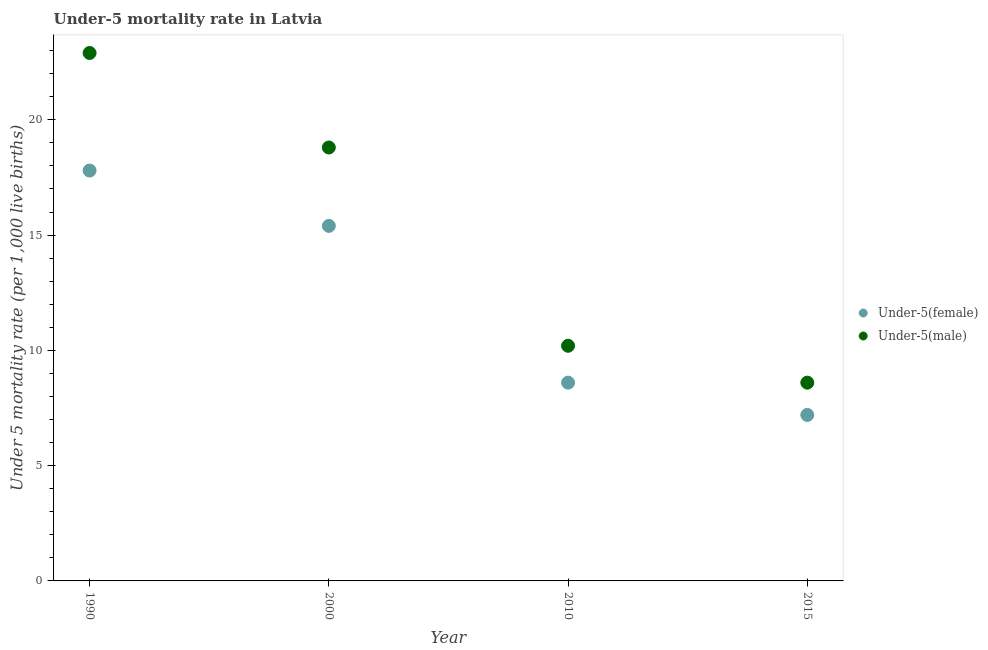Is the number of dotlines equal to the number of legend labels?
Offer a terse response. Yes. What is the under-5 male mortality rate in 2010?
Make the answer very short. 10.2. Across all years, what is the maximum under-5 female mortality rate?
Give a very brief answer. 17.8. In which year was the under-5 male mortality rate maximum?
Your answer should be very brief. 1990. In which year was the under-5 female mortality rate minimum?
Your response must be concise. 2015. What is the total under-5 male mortality rate in the graph?
Your response must be concise. 60.5. What is the difference between the under-5 male mortality rate in 1990 and that in 2015?
Your response must be concise. 14.3. What is the difference between the under-5 female mortality rate in 2010 and the under-5 male mortality rate in 1990?
Your answer should be very brief. -14.3. What is the average under-5 female mortality rate per year?
Offer a terse response. 12.25. In the year 2000, what is the difference between the under-5 male mortality rate and under-5 female mortality rate?
Your answer should be compact. 3.4. In how many years, is the under-5 female mortality rate greater than 22?
Offer a very short reply. 0. What is the ratio of the under-5 male mortality rate in 1990 to that in 2015?
Provide a short and direct response. 2.66. What is the difference between the highest and the second highest under-5 female mortality rate?
Your answer should be very brief. 2.4. What is the difference between the highest and the lowest under-5 female mortality rate?
Give a very brief answer. 10.6. Is the sum of the under-5 female mortality rate in 2010 and 2015 greater than the maximum under-5 male mortality rate across all years?
Offer a very short reply. No. Does the under-5 female mortality rate monotonically increase over the years?
Your response must be concise. No. Is the under-5 male mortality rate strictly greater than the under-5 female mortality rate over the years?
Ensure brevity in your answer.  Yes. How many dotlines are there?
Your answer should be very brief. 2. How many years are there in the graph?
Your answer should be very brief. 4. Does the graph contain any zero values?
Provide a succinct answer. No. How many legend labels are there?
Make the answer very short. 2. What is the title of the graph?
Give a very brief answer. Under-5 mortality rate in Latvia. Does "Primary completion rate" appear as one of the legend labels in the graph?
Provide a short and direct response. No. What is the label or title of the X-axis?
Your response must be concise. Year. What is the label or title of the Y-axis?
Give a very brief answer. Under 5 mortality rate (per 1,0 live births). What is the Under 5 mortality rate (per 1,000 live births) in Under-5(male) in 1990?
Ensure brevity in your answer.  22.9. What is the Under 5 mortality rate (per 1,000 live births) of Under-5(male) in 2000?
Provide a short and direct response. 18.8. What is the Under 5 mortality rate (per 1,000 live births) of Under-5(female) in 2015?
Provide a succinct answer. 7.2. What is the Under 5 mortality rate (per 1,000 live births) in Under-5(male) in 2015?
Offer a terse response. 8.6. Across all years, what is the maximum Under 5 mortality rate (per 1,000 live births) in Under-5(male)?
Offer a very short reply. 22.9. Across all years, what is the minimum Under 5 mortality rate (per 1,000 live births) in Under-5(female)?
Your answer should be compact. 7.2. What is the total Under 5 mortality rate (per 1,000 live births) in Under-5(female) in the graph?
Your answer should be compact. 49. What is the total Under 5 mortality rate (per 1,000 live births) of Under-5(male) in the graph?
Provide a short and direct response. 60.5. What is the difference between the Under 5 mortality rate (per 1,000 live births) of Under-5(male) in 1990 and that in 2000?
Provide a succinct answer. 4.1. What is the difference between the Under 5 mortality rate (per 1,000 live births) in Under-5(female) in 1990 and that in 2010?
Provide a succinct answer. 9.2. What is the difference between the Under 5 mortality rate (per 1,000 live births) of Under-5(female) in 1990 and that in 2015?
Offer a terse response. 10.6. What is the difference between the Under 5 mortality rate (per 1,000 live births) in Under-5(male) in 2000 and that in 2015?
Make the answer very short. 10.2. What is the difference between the Under 5 mortality rate (per 1,000 live births) in Under-5(female) in 1990 and the Under 5 mortality rate (per 1,000 live births) in Under-5(male) in 2000?
Provide a short and direct response. -1. What is the difference between the Under 5 mortality rate (per 1,000 live births) in Under-5(female) in 2000 and the Under 5 mortality rate (per 1,000 live births) in Under-5(male) in 2010?
Offer a very short reply. 5.2. What is the difference between the Under 5 mortality rate (per 1,000 live births) of Under-5(female) in 2010 and the Under 5 mortality rate (per 1,000 live births) of Under-5(male) in 2015?
Your answer should be very brief. 0. What is the average Under 5 mortality rate (per 1,000 live births) in Under-5(female) per year?
Your response must be concise. 12.25. What is the average Under 5 mortality rate (per 1,000 live births) in Under-5(male) per year?
Provide a short and direct response. 15.12. In the year 2015, what is the difference between the Under 5 mortality rate (per 1,000 live births) of Under-5(female) and Under 5 mortality rate (per 1,000 live births) of Under-5(male)?
Provide a short and direct response. -1.4. What is the ratio of the Under 5 mortality rate (per 1,000 live births) in Under-5(female) in 1990 to that in 2000?
Ensure brevity in your answer.  1.16. What is the ratio of the Under 5 mortality rate (per 1,000 live births) of Under-5(male) in 1990 to that in 2000?
Provide a short and direct response. 1.22. What is the ratio of the Under 5 mortality rate (per 1,000 live births) of Under-5(female) in 1990 to that in 2010?
Keep it short and to the point. 2.07. What is the ratio of the Under 5 mortality rate (per 1,000 live births) of Under-5(male) in 1990 to that in 2010?
Ensure brevity in your answer.  2.25. What is the ratio of the Under 5 mortality rate (per 1,000 live births) in Under-5(female) in 1990 to that in 2015?
Keep it short and to the point. 2.47. What is the ratio of the Under 5 mortality rate (per 1,000 live births) in Under-5(male) in 1990 to that in 2015?
Your answer should be compact. 2.66. What is the ratio of the Under 5 mortality rate (per 1,000 live births) in Under-5(female) in 2000 to that in 2010?
Provide a short and direct response. 1.79. What is the ratio of the Under 5 mortality rate (per 1,000 live births) of Under-5(male) in 2000 to that in 2010?
Provide a succinct answer. 1.84. What is the ratio of the Under 5 mortality rate (per 1,000 live births) in Under-5(female) in 2000 to that in 2015?
Ensure brevity in your answer.  2.14. What is the ratio of the Under 5 mortality rate (per 1,000 live births) in Under-5(male) in 2000 to that in 2015?
Make the answer very short. 2.19. What is the ratio of the Under 5 mortality rate (per 1,000 live births) in Under-5(female) in 2010 to that in 2015?
Keep it short and to the point. 1.19. What is the ratio of the Under 5 mortality rate (per 1,000 live births) of Under-5(male) in 2010 to that in 2015?
Your answer should be very brief. 1.19. What is the difference between the highest and the second highest Under 5 mortality rate (per 1,000 live births) in Under-5(female)?
Provide a succinct answer. 2.4. What is the difference between the highest and the lowest Under 5 mortality rate (per 1,000 live births) of Under-5(female)?
Ensure brevity in your answer.  10.6. 